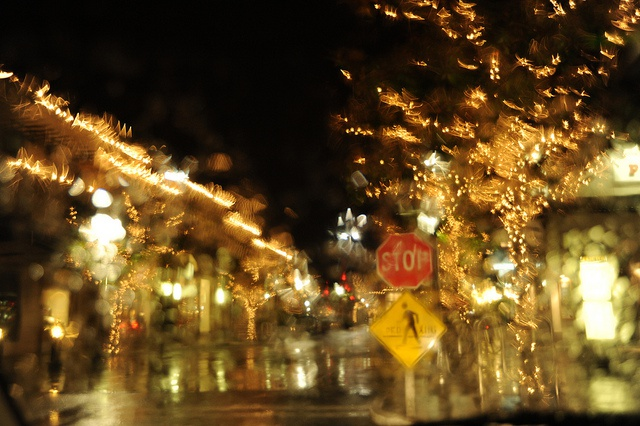Describe the objects in this image and their specific colors. I can see a stop sign in black, red, brown, and orange tones in this image. 